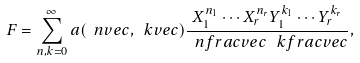Convert formula to latex. <formula><loc_0><loc_0><loc_500><loc_500>F = \sum _ { n , k = 0 } ^ { \infty } a ( \ n v e c , \ k v e c ) \frac { X _ { 1 } ^ { n _ { 1 } } \cdots X _ { r } ^ { n _ { r } } Y _ { 1 } ^ { k _ { 1 } } \cdots Y _ { r } ^ { k _ { r } } } { \ n f r a c v e c \, \ k f r a c v e c } ,</formula> 